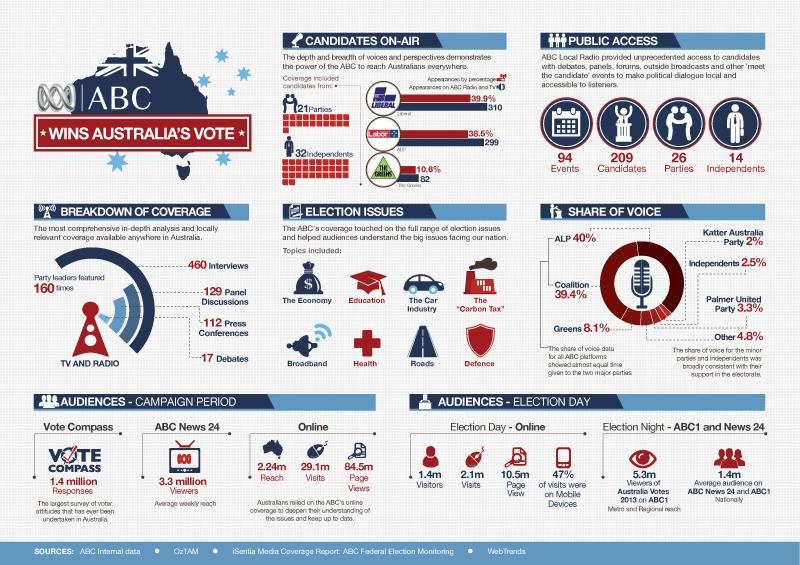Indicate a few pertinent items in this graphic. Approximately 1.4 million responses were recorded in vote compass. According to data, ABC News 24 received 3.3 million views. ABC Local Radio conducted 94 events. ABC Local Radio provided unprecedented access to 209 candidates. Eight election-related issues were reported by ABC. 